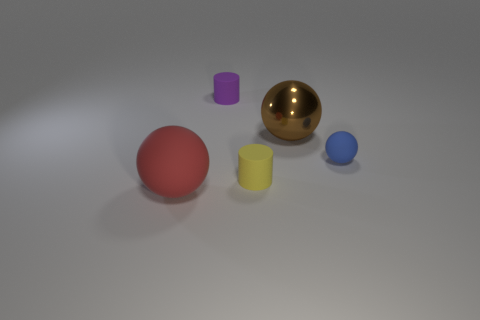Add 5 blue matte spheres. How many objects exist? 10 Subtract all cylinders. How many objects are left? 3 Add 4 red balls. How many red balls exist? 5 Subtract 0 green spheres. How many objects are left? 5 Subtract all brown balls. Subtract all large brown balls. How many objects are left? 3 Add 4 tiny things. How many tiny things are left? 7 